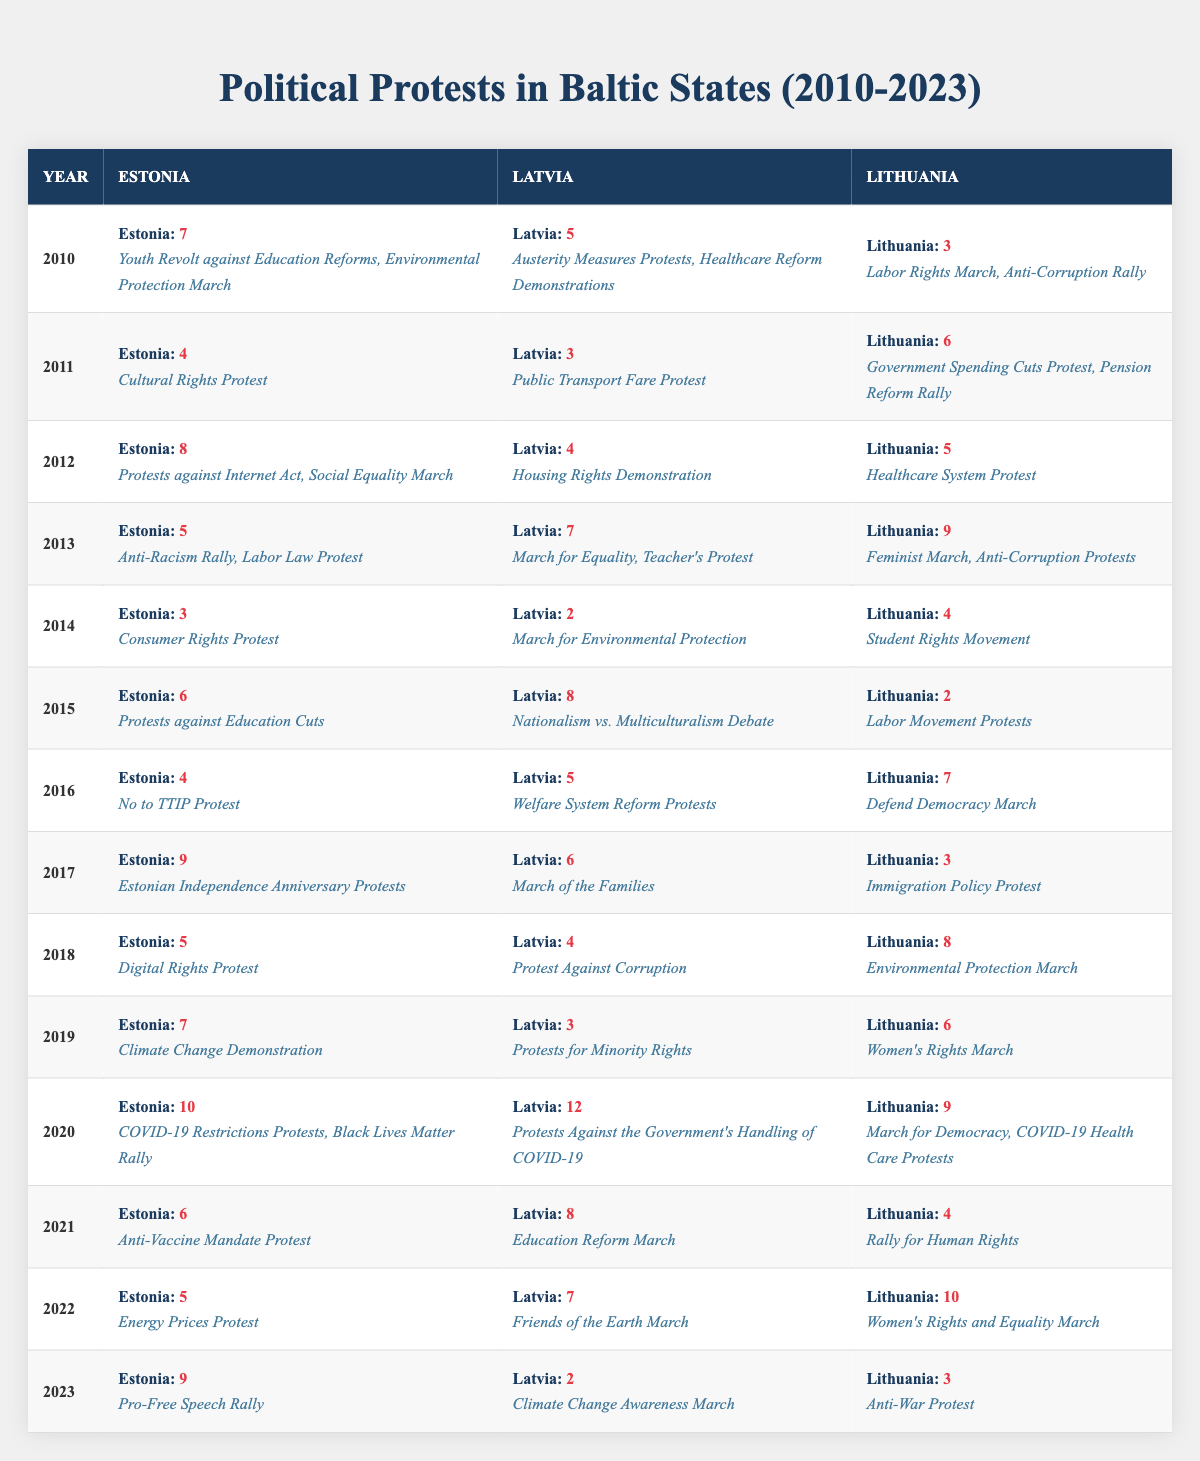What was the year with the highest number of protests in Latvia? In the table, I can see that the year 2020 has the highest number of protests in Latvia, totaling 12 protests.
Answer: 2020 Which country had the most protests in 2013? By comparing the numbers in the 2013 row, I see Lithuania had the highest number of protests at 9.
Answer: Lithuania How many protests were recorded in total across all three countries in 2021? To calculate the total for 2021, I add the numbers: Estonia (6) + Latvia (8) + Lithuania (4) = 18.
Answer: 18 Did Estonia have more protests in 2015 than in 2016? In 2015, Estonia had 6 protests and in 2016, it had 4 protests, so yes, Estonia had more protests in 2015 than in 2016.
Answer: Yes What was the average number of protests in Lithuania from 2010 to 2015? Adding the number of protests from 2010 to 2015, we get: 3 + 6 + 5 + 9 + 4 + 2 = 29. Since there are 6 years, I divide 29 by 6, which gives approximately 4.83.
Answer: 4.83 Which year saw the least number of protests in Latvia and how many were there? Looking at the Latvia column, the least number of protests was in 2014 with 2 recorded.
Answer: 2014, 2 Was there a year when all Baltic states had an equal or similar number of protests? By checking each year, I find that in 2014 and 2015, the number of protests across the three countries varied significantly, suggesting there was no year of equal numbers.
Answer: No What trend can be observed in the number of total protests in Estonia from 2010 to 2023? By looking at the numbers for Estonia, I can assess the overall trend: it fluctuated, starting at 7 in 2010, peaking at 10 in 2020, then dropped to 9 in 2023, showing fluctuations without a consistent upward or downward trend.
Answer: Fluctuating In which year did Lithuania experience the highest increase in protests compared to the previous year? I review each year for Lithuania: the increase from 2019 (6 protests) to 2020 (9 protests) is the highest increase of 3 protests when comparing year over year.
Answer: 2020 How many protests were registered in Estonia during even-numbered years between 2010 and 2022? The even-numbered years are 2010 (7), 2012 (8), 2014 (3), 2016 (4), 2018 (5), and 2022 (5). The total of these numbers is 7 + 8 + 3 + 4 + 5 + 5 = 32.
Answer: 32 